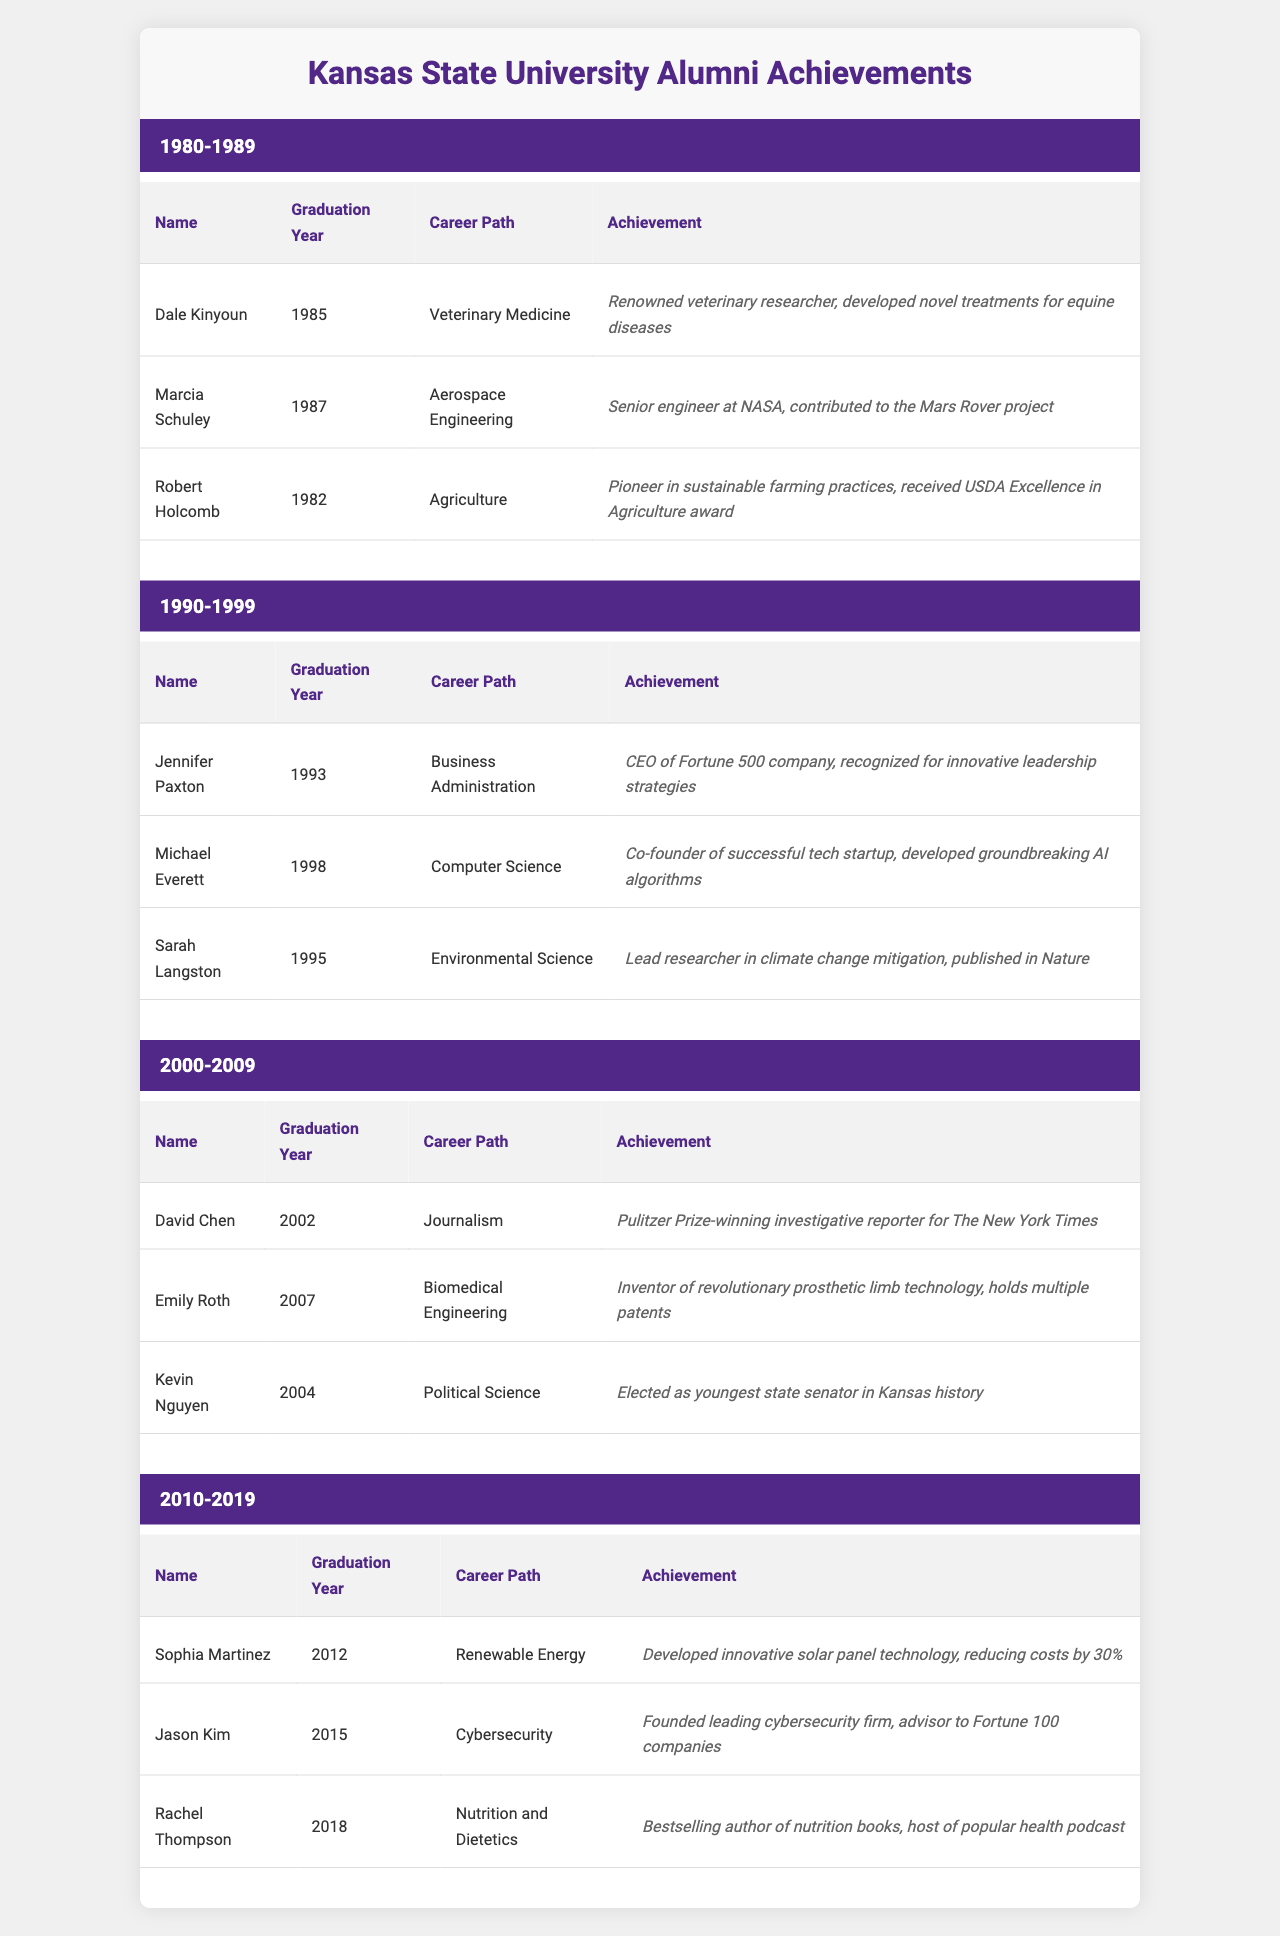What is the notable achievement of Dale Kinyoun? Dale Kinyoun, who graduated in 1985, is noted for being a renowned veterinary researcher who developed novel treatments for equine diseases.
Answer: Developed novel treatments for equine diseases Who was a senior engineer at NASA, and what year did they graduate? Marcia Schuley graduated in 1987 and is recognized as a senior engineer at NASA, contributing to the Mars Rover project.
Answer: Marcia Schuley graduated in 1987 Which alumni group has the most notable achievements in renewable energy? Looking at the table, only one notable alumni, Sophia Martinez, from the 2010-2019 decade is focused on renewable energy, thus she is the sole representative in this field.
Answer: 2010-2019 decade Which career path appears most frequently across the decades in the notable alumni? The career paths listed do not repeat as they are unique to each notable alumni mentioned, indicating a diversity in career paths across the decades.
Answer: None repeated Is there an alumnus who received a prestigious award in journalism, and if so, who? Yes, David Chen is noted as a Pulitzer Prize-winning investigative reporter for The New York Times, indicating a significant achievement in journalism.
Answer: David Chen What is the average graduation year of the notable alumni from the 1990-1999 decade? The graduation years for notable alumni in that decade are 1993, 1995, and 1998. Summing these gives a total of 593. Dividing by 3 gives an average of 197.67, rounding to 1996.
Answer: 1996 Which notable alumnus was the youngest state senator in Kansas history? Kevin Nguyen, who graduated in 2004, is noted as the youngest state senator in Kansas history, making him a standout in political accomplishments.
Answer: Kevin Nguyen What significant contribution did Emily Roth make in her career? Emily Roth, graduating in 2007, is recognized for inventing revolutionary prosthetic limb technology and holds multiple patents, highlighting her innovation in biomedical engineering.
Answer: Invented prosthetic limb technology Which notable alumni focused on environmental science and what is their achievement? Sarah Langston, who graduated in 1995, is a lead researcher in climate change mitigation and has had research published in Nature, emphasizing her contributions to environmental science.
Answer: Lead researcher in climate change mitigation Is there a notable alumnus who contributed to the Mars Rover project, and what did they graduate in? Yes, Marcia Schuley contributed to the Mars Rover project and graduated in Aerospace Engineering in 1987, showcasing her achievement in aerospace engineering.
Answer: Graduated in Aerospace Engineering in 1987 Which decade had alumni involved in both veterinary medicine and agriculture? The 1980-1989 decade had notable alumni with Dale Kinyoun in veterinary medicine and Robert Holcomb in agriculture, indicating diverse fields within the same decade.
Answer: 1980-1989 decade 